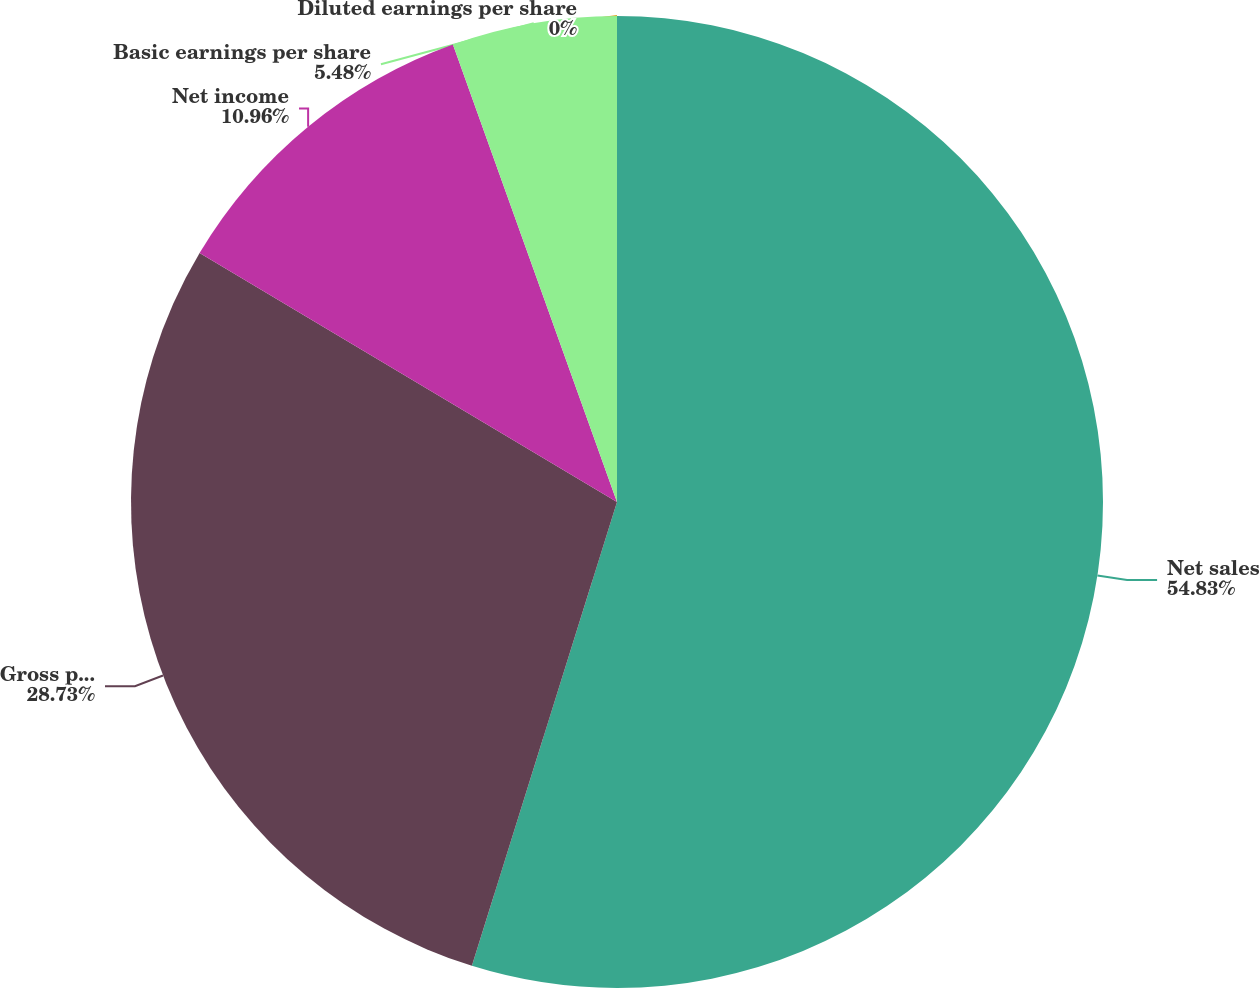Convert chart to OTSL. <chart><loc_0><loc_0><loc_500><loc_500><pie_chart><fcel>Net sales<fcel>Gross profit<fcel>Net income<fcel>Basic earnings per share<fcel>Diluted earnings per share<nl><fcel>54.82%<fcel>28.73%<fcel>10.96%<fcel>5.48%<fcel>0.0%<nl></chart> 